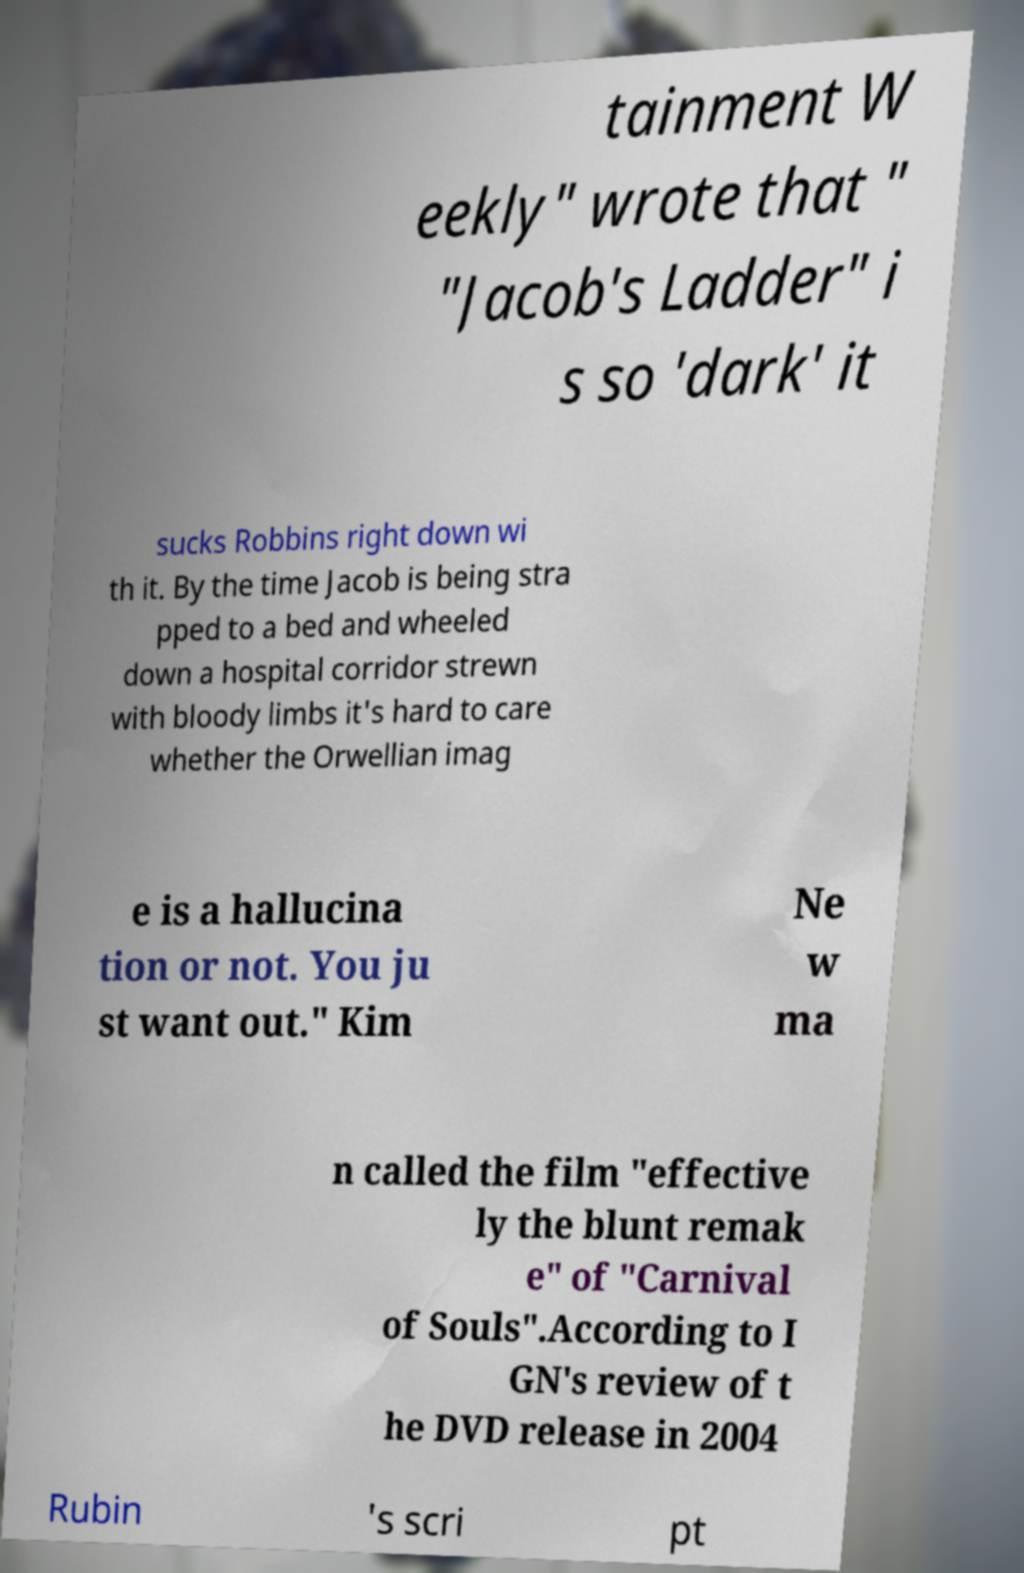Please read and relay the text visible in this image. What does it say? tainment W eekly" wrote that " "Jacob's Ladder" i s so 'dark' it sucks Robbins right down wi th it. By the time Jacob is being stra pped to a bed and wheeled down a hospital corridor strewn with bloody limbs it's hard to care whether the Orwellian imag e is a hallucina tion or not. You ju st want out." Kim Ne w ma n called the film "effective ly the blunt remak e" of "Carnival of Souls".According to I GN's review of t he DVD release in 2004 Rubin 's scri pt 